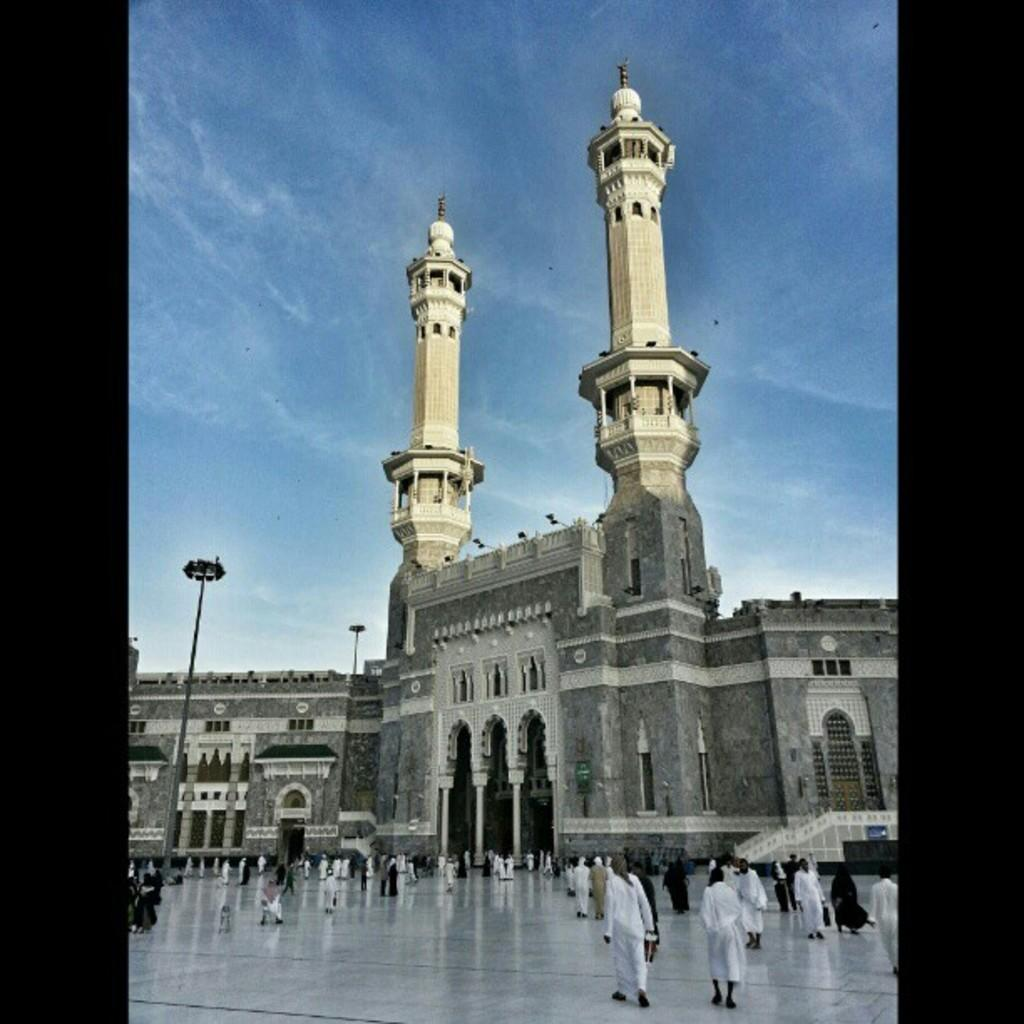What structure is present in the image? There is a building in the image. What are the people in the image doing? The people are walking in the image. What are the people wearing? The people are wearing clothes. What are the light sources in the image? There are light poles in the image. What surface can be seen under the people's feet? The floor is visible in the image. What is visible above the building? The sky is visible in the image. Can you tell me how many wounds the mom has in the image? There is no mom or any wounds present in the image. Are there any bikes visible in the image? There are no bikes visible in the image. 